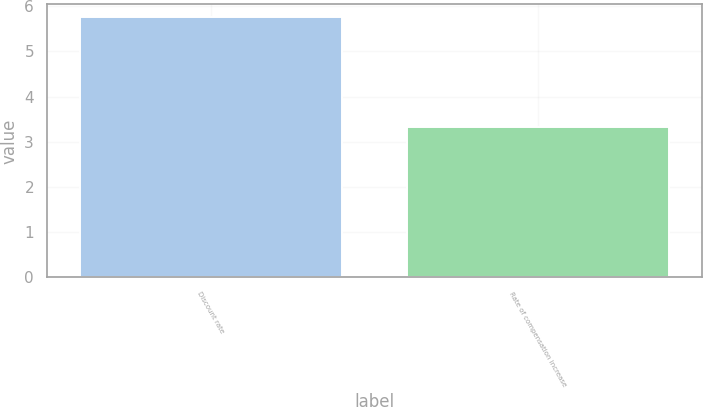Convert chart. <chart><loc_0><loc_0><loc_500><loc_500><bar_chart><fcel>Discount rate<fcel>Rate of compensation increase<nl><fcel>5.75<fcel>3.33<nl></chart> 